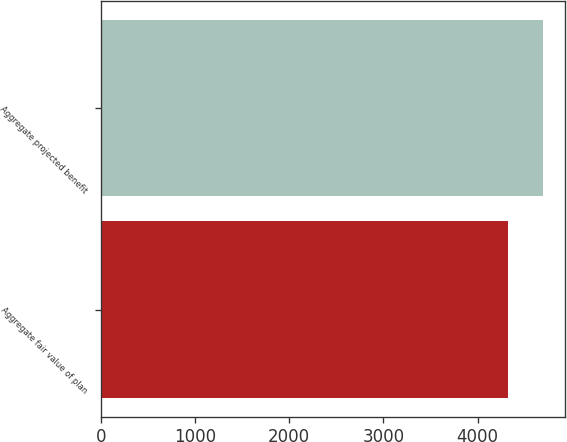<chart> <loc_0><loc_0><loc_500><loc_500><bar_chart><fcel>Aggregate fair value of plan<fcel>Aggregate projected benefit<nl><fcel>4325<fcel>4688<nl></chart> 